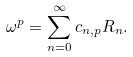<formula> <loc_0><loc_0><loc_500><loc_500>\omega ^ { p } = \sum _ { n = 0 } ^ { \infty } c _ { n , p } R _ { n } .</formula> 